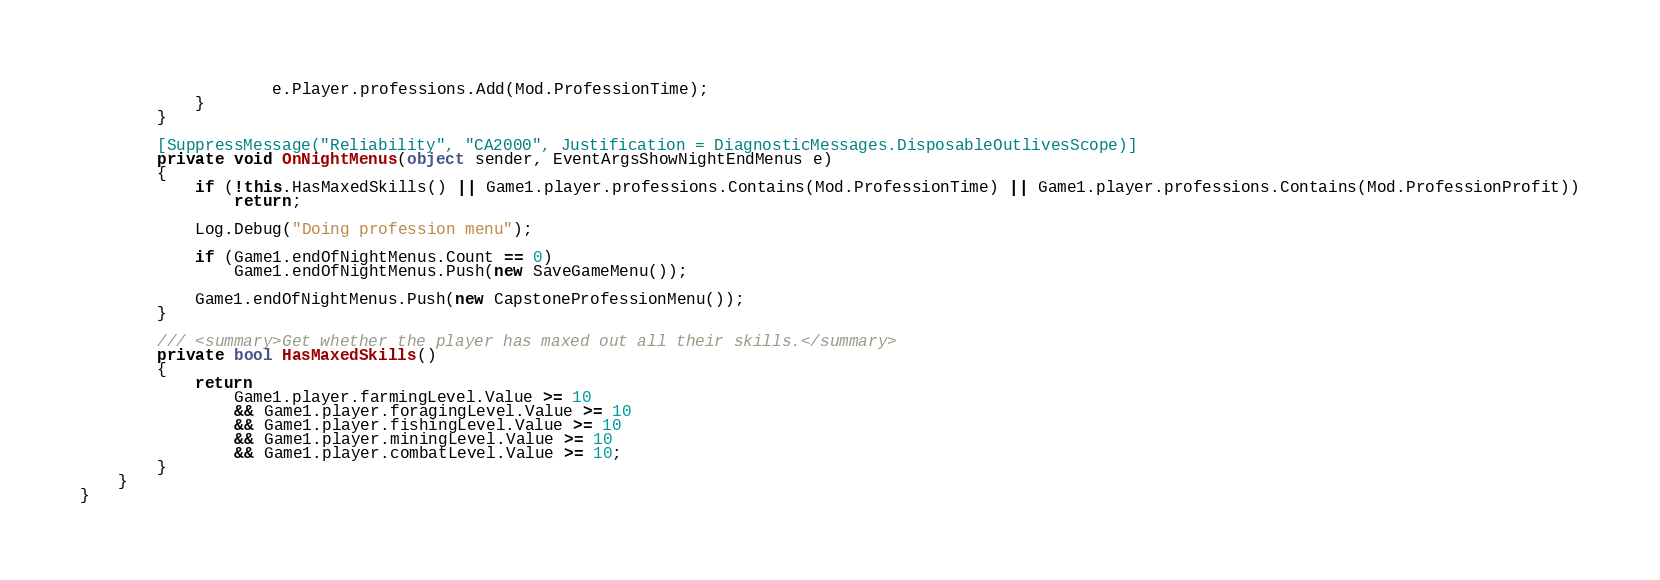<code> <loc_0><loc_0><loc_500><loc_500><_C#_>                    e.Player.professions.Add(Mod.ProfessionTime);
            }
        }

        [SuppressMessage("Reliability", "CA2000", Justification = DiagnosticMessages.DisposableOutlivesScope)]
        private void OnNightMenus(object sender, EventArgsShowNightEndMenus e)
        {
            if (!this.HasMaxedSkills() || Game1.player.professions.Contains(Mod.ProfessionTime) || Game1.player.professions.Contains(Mod.ProfessionProfit))
                return;

            Log.Debug("Doing profession menu");

            if (Game1.endOfNightMenus.Count == 0)
                Game1.endOfNightMenus.Push(new SaveGameMenu());

            Game1.endOfNightMenus.Push(new CapstoneProfessionMenu());
        }

        /// <summary>Get whether the player has maxed out all their skills.</summary>
        private bool HasMaxedSkills()
        {
            return
                Game1.player.farmingLevel.Value >= 10
                && Game1.player.foragingLevel.Value >= 10
                && Game1.player.fishingLevel.Value >= 10
                && Game1.player.miningLevel.Value >= 10
                && Game1.player.combatLevel.Value >= 10;
        }
    }
}
</code> 